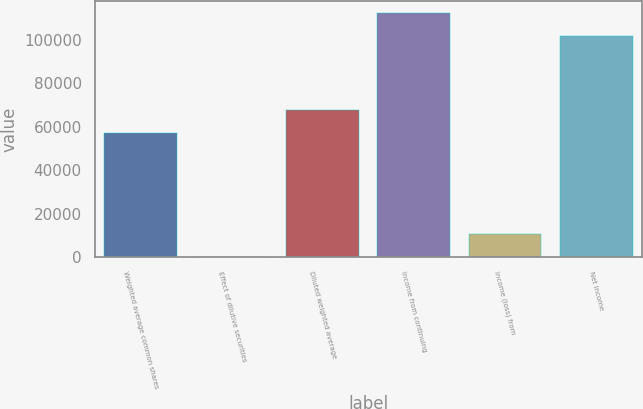Convert chart to OTSL. <chart><loc_0><loc_0><loc_500><loc_500><bar_chart><fcel>Weighted average common shares<fcel>Effect of dilutive securities<fcel>Diluted weighted average<fcel>Income from continuing<fcel>Income (loss) from<fcel>Net Income<nl><fcel>57143<fcel>285<fcel>67575.9<fcel>112211<fcel>10717.9<fcel>101778<nl></chart> 